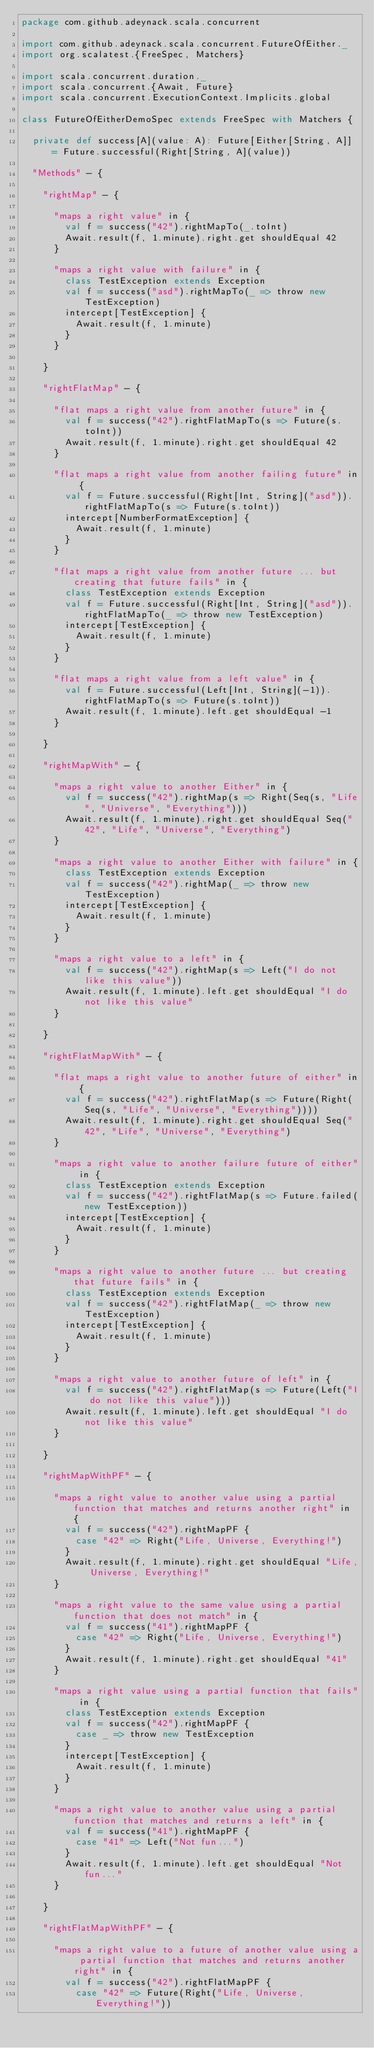<code> <loc_0><loc_0><loc_500><loc_500><_Scala_>package com.github.adeynack.scala.concurrent

import com.github.adeynack.scala.concurrent.FutureOfEither._
import org.scalatest.{FreeSpec, Matchers}

import scala.concurrent.duration._
import scala.concurrent.{Await, Future}
import scala.concurrent.ExecutionContext.Implicits.global

class FutureOfEitherDemoSpec extends FreeSpec with Matchers {

  private def success[A](value: A): Future[Either[String, A]] = Future.successful(Right[String, A](value))

  "Methods" - {

    "rightMap" - {

      "maps a right value" in {
        val f = success("42").rightMapTo(_.toInt)
        Await.result(f, 1.minute).right.get shouldEqual 42
      }

      "maps a right value with failure" in {
        class TestException extends Exception
        val f = success("asd").rightMapTo(_ => throw new TestException)
        intercept[TestException] {
          Await.result(f, 1.minute)
        }
      }

    }

    "rightFlatMap" - {

      "flat maps a right value from another future" in {
        val f = success("42").rightFlatMapTo(s => Future(s.toInt))
        Await.result(f, 1.minute).right.get shouldEqual 42
      }

      "flat maps a right value from another failing future" in {
        val f = Future.successful(Right[Int, String]("asd")).rightFlatMapTo(s => Future(s.toInt))
        intercept[NumberFormatException] {
          Await.result(f, 1.minute)
        }
      }

      "flat maps a right value from another future ... but creating that future fails" in {
        class TestException extends Exception
        val f = Future.successful(Right[Int, String]("asd")).rightFlatMapTo(_ => throw new TestException)
        intercept[TestException] {
          Await.result(f, 1.minute)
        }
      }

      "flat maps a right value from a left value" in {
        val f = Future.successful(Left[Int, String](-1)).rightFlatMapTo(s => Future(s.toInt))
        Await.result(f, 1.minute).left.get shouldEqual -1
      }

    }

    "rightMapWith" - {

      "maps a right value to another Either" in {
        val f = success("42").rightMap(s => Right(Seq(s, "Life", "Universe", "Everything")))
        Await.result(f, 1.minute).right.get shouldEqual Seq("42", "Life", "Universe", "Everything")
      }

      "maps a right value to another Either with failure" in {
        class TestException extends Exception
        val f = success("42").rightMap(_ => throw new TestException)
        intercept[TestException] {
          Await.result(f, 1.minute)
        }
      }

      "maps a right value to a left" in {
        val f = success("42").rightMap(s => Left("I do not like this value"))
        Await.result(f, 1.minute).left.get shouldEqual "I do not like this value"
      }

    }

    "rightFlatMapWith" - {

      "flat maps a right value to another future of either" in {
        val f = success("42").rightFlatMap(s => Future(Right(Seq(s, "Life", "Universe", "Everything"))))
        Await.result(f, 1.minute).right.get shouldEqual Seq("42", "Life", "Universe", "Everything")
      }

      "maps a right value to another failure future of either" in {
        class TestException extends Exception
        val f = success("42").rightFlatMap(s => Future.failed(new TestException))
        intercept[TestException] {
          Await.result(f, 1.minute)
        }
      }

      "maps a right value to another future ... but creating that future fails" in {
        class TestException extends Exception
        val f = success("42").rightFlatMap(_ => throw new TestException)
        intercept[TestException] {
          Await.result(f, 1.minute)
        }
      }

      "maps a right value to another future of left" in {
        val f = success("42").rightFlatMap(s => Future(Left("I do not like this value")))
        Await.result(f, 1.minute).left.get shouldEqual "I do not like this value"
      }

    }

    "rightMapWithPF" - {

      "maps a right value to another value using a partial function that matches and returns another right" in {
        val f = success("42").rightMapPF {
          case "42" => Right("Life, Universe, Everything!")
        }
        Await.result(f, 1.minute).right.get shouldEqual "Life, Universe, Everything!"
      }

      "maps a right value to the same value using a partial function that does not match" in {
        val f = success("41").rightMapPF {
          case "42" => Right("Life, Universe, Everything!")
        }
        Await.result(f, 1.minute).right.get shouldEqual "41"
      }

      "maps a right value using a partial function that fails" in {
        class TestException extends Exception
        val f = success("42").rightMapPF {
          case _ => throw new TestException
        }
        intercept[TestException] {
          Await.result(f, 1.minute)
        }
      }

      "maps a right value to another value using a partial function that matches and returns a left" in {
        val f = success("41").rightMapPF {
          case "41" => Left("Not fun...")
        }
        Await.result(f, 1.minute).left.get shouldEqual "Not fun..."
      }

    }

    "rightFlatMapWithPF" - {

      "maps a right value to a future of another value using a partial function that matches and returns another right" in {
        val f = success("42").rightFlatMapPF {
          case "42" => Future(Right("Life, Universe, Everything!"))</code> 